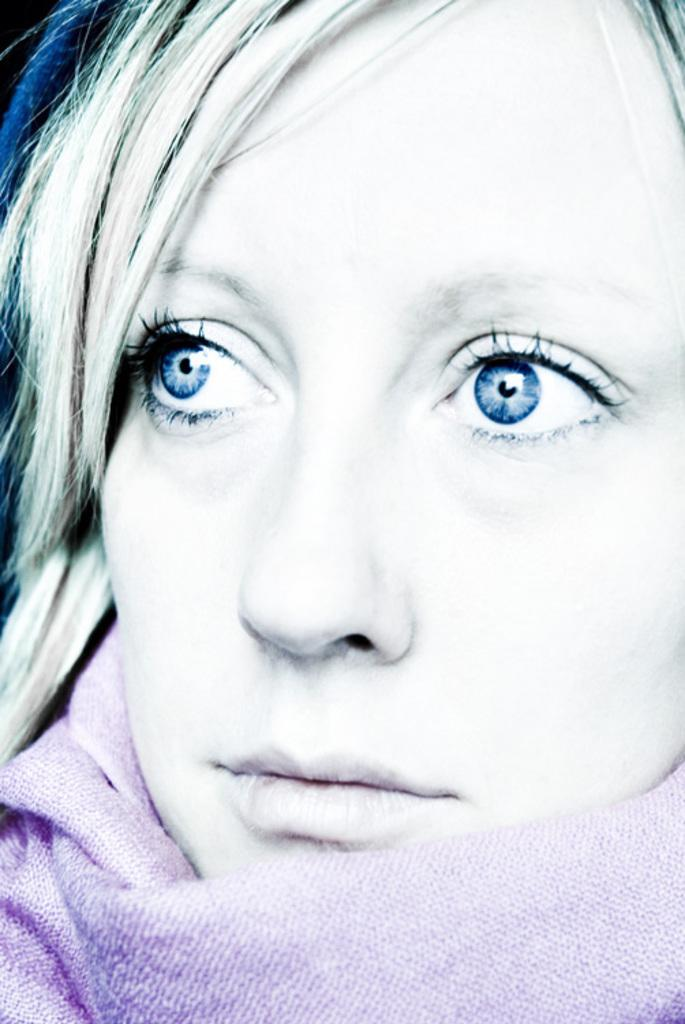What is the main subject of the image? The main subject of the image is a woman. What is the woman wearing in the image? The woman is wearing a scarf. How many legs does the giraffe have in the image? There is no giraffe present in the image. Is the woman in the image crying? The image does not show the woman crying, nor does it provide any information about her emotional state. 